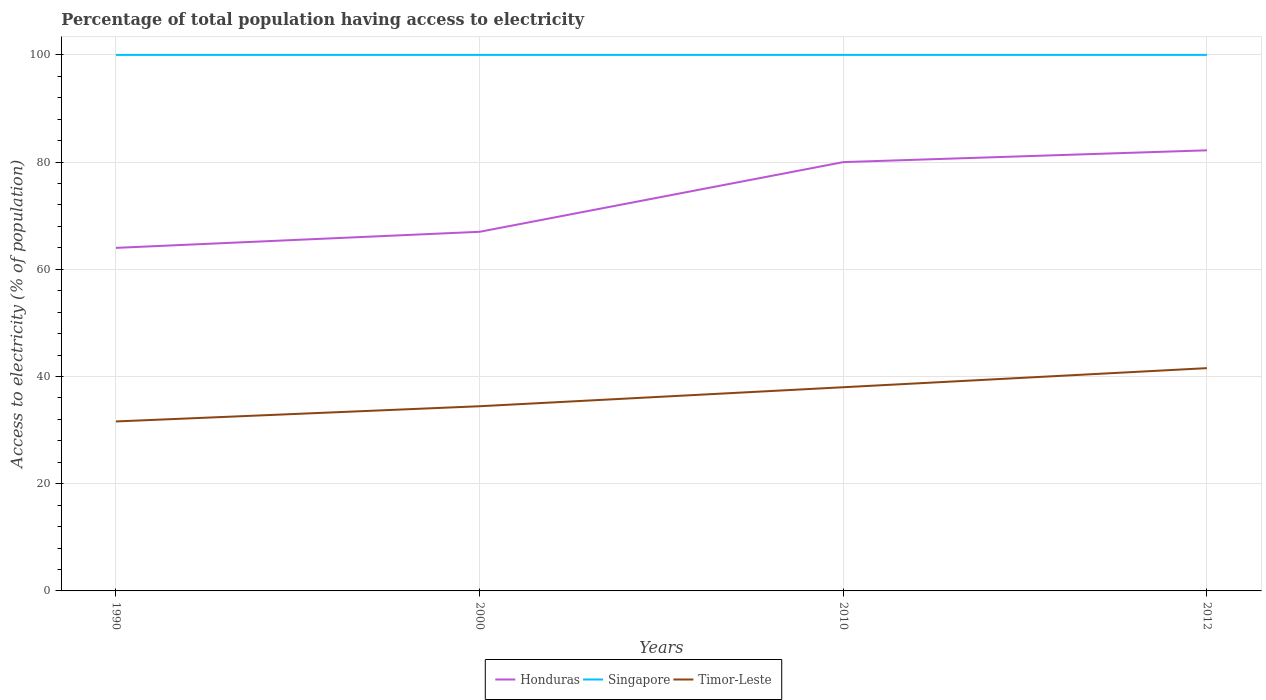How many different coloured lines are there?
Keep it short and to the point. 3. Does the line corresponding to Honduras intersect with the line corresponding to Singapore?
Your answer should be compact. No. Across all years, what is the maximum percentage of population that have access to electricity in Honduras?
Offer a terse response. 64. In which year was the percentage of population that have access to electricity in Singapore maximum?
Keep it short and to the point. 1990. What is the difference between the highest and the second highest percentage of population that have access to electricity in Honduras?
Keep it short and to the point. 18.2. What is the difference between the highest and the lowest percentage of population that have access to electricity in Timor-Leste?
Give a very brief answer. 2. Is the percentage of population that have access to electricity in Timor-Leste strictly greater than the percentage of population that have access to electricity in Honduras over the years?
Give a very brief answer. Yes. Does the graph contain grids?
Ensure brevity in your answer.  Yes. Where does the legend appear in the graph?
Make the answer very short. Bottom center. How many legend labels are there?
Provide a succinct answer. 3. How are the legend labels stacked?
Offer a terse response. Horizontal. What is the title of the graph?
Your answer should be very brief. Percentage of total population having access to electricity. What is the label or title of the Y-axis?
Provide a short and direct response. Access to electricity (% of population). What is the Access to electricity (% of population) in Honduras in 1990?
Offer a very short reply. 64. What is the Access to electricity (% of population) of Singapore in 1990?
Offer a very short reply. 100. What is the Access to electricity (% of population) in Timor-Leste in 1990?
Offer a terse response. 31.62. What is the Access to electricity (% of population) of Honduras in 2000?
Offer a very short reply. 67. What is the Access to electricity (% of population) in Timor-Leste in 2000?
Provide a short and direct response. 34.46. What is the Access to electricity (% of population) in Timor-Leste in 2010?
Your response must be concise. 38. What is the Access to electricity (% of population) of Honduras in 2012?
Keep it short and to the point. 82.2. What is the Access to electricity (% of population) of Timor-Leste in 2012?
Ensure brevity in your answer.  41.56. Across all years, what is the maximum Access to electricity (% of population) of Honduras?
Provide a short and direct response. 82.2. Across all years, what is the maximum Access to electricity (% of population) in Timor-Leste?
Ensure brevity in your answer.  41.56. Across all years, what is the minimum Access to electricity (% of population) of Timor-Leste?
Your answer should be very brief. 31.62. What is the total Access to electricity (% of population) of Honduras in the graph?
Make the answer very short. 293.2. What is the total Access to electricity (% of population) in Timor-Leste in the graph?
Offer a very short reply. 145.63. What is the difference between the Access to electricity (% of population) in Singapore in 1990 and that in 2000?
Make the answer very short. 0. What is the difference between the Access to electricity (% of population) in Timor-Leste in 1990 and that in 2000?
Your answer should be very brief. -2.84. What is the difference between the Access to electricity (% of population) of Honduras in 1990 and that in 2010?
Offer a very short reply. -16. What is the difference between the Access to electricity (% of population) of Timor-Leste in 1990 and that in 2010?
Provide a short and direct response. -6.38. What is the difference between the Access to electricity (% of population) of Honduras in 1990 and that in 2012?
Ensure brevity in your answer.  -18.2. What is the difference between the Access to electricity (% of population) of Singapore in 1990 and that in 2012?
Provide a succinct answer. 0. What is the difference between the Access to electricity (% of population) in Timor-Leste in 1990 and that in 2012?
Your answer should be very brief. -9.95. What is the difference between the Access to electricity (% of population) in Honduras in 2000 and that in 2010?
Your answer should be compact. -13. What is the difference between the Access to electricity (% of population) of Singapore in 2000 and that in 2010?
Offer a very short reply. 0. What is the difference between the Access to electricity (% of population) in Timor-Leste in 2000 and that in 2010?
Offer a terse response. -3.54. What is the difference between the Access to electricity (% of population) of Honduras in 2000 and that in 2012?
Give a very brief answer. -15.2. What is the difference between the Access to electricity (% of population) in Singapore in 2000 and that in 2012?
Give a very brief answer. 0. What is the difference between the Access to electricity (% of population) of Timor-Leste in 2000 and that in 2012?
Give a very brief answer. -7.11. What is the difference between the Access to electricity (% of population) in Honduras in 2010 and that in 2012?
Your response must be concise. -2.2. What is the difference between the Access to electricity (% of population) of Singapore in 2010 and that in 2012?
Provide a short and direct response. 0. What is the difference between the Access to electricity (% of population) of Timor-Leste in 2010 and that in 2012?
Provide a short and direct response. -3.56. What is the difference between the Access to electricity (% of population) of Honduras in 1990 and the Access to electricity (% of population) of Singapore in 2000?
Your response must be concise. -36. What is the difference between the Access to electricity (% of population) in Honduras in 1990 and the Access to electricity (% of population) in Timor-Leste in 2000?
Your response must be concise. 29.54. What is the difference between the Access to electricity (% of population) of Singapore in 1990 and the Access to electricity (% of population) of Timor-Leste in 2000?
Give a very brief answer. 65.54. What is the difference between the Access to electricity (% of population) in Honduras in 1990 and the Access to electricity (% of population) in Singapore in 2010?
Ensure brevity in your answer.  -36. What is the difference between the Access to electricity (% of population) of Singapore in 1990 and the Access to electricity (% of population) of Timor-Leste in 2010?
Provide a short and direct response. 62. What is the difference between the Access to electricity (% of population) of Honduras in 1990 and the Access to electricity (% of population) of Singapore in 2012?
Offer a very short reply. -36. What is the difference between the Access to electricity (% of population) of Honduras in 1990 and the Access to electricity (% of population) of Timor-Leste in 2012?
Ensure brevity in your answer.  22.44. What is the difference between the Access to electricity (% of population) of Singapore in 1990 and the Access to electricity (% of population) of Timor-Leste in 2012?
Make the answer very short. 58.44. What is the difference between the Access to electricity (% of population) of Honduras in 2000 and the Access to electricity (% of population) of Singapore in 2010?
Provide a succinct answer. -33. What is the difference between the Access to electricity (% of population) of Honduras in 2000 and the Access to electricity (% of population) of Singapore in 2012?
Your response must be concise. -33. What is the difference between the Access to electricity (% of population) of Honduras in 2000 and the Access to electricity (% of population) of Timor-Leste in 2012?
Offer a very short reply. 25.44. What is the difference between the Access to electricity (% of population) of Singapore in 2000 and the Access to electricity (% of population) of Timor-Leste in 2012?
Your answer should be very brief. 58.44. What is the difference between the Access to electricity (% of population) in Honduras in 2010 and the Access to electricity (% of population) in Timor-Leste in 2012?
Provide a short and direct response. 38.44. What is the difference between the Access to electricity (% of population) of Singapore in 2010 and the Access to electricity (% of population) of Timor-Leste in 2012?
Your answer should be compact. 58.44. What is the average Access to electricity (% of population) in Honduras per year?
Your answer should be compact. 73.3. What is the average Access to electricity (% of population) in Singapore per year?
Your response must be concise. 100. What is the average Access to electricity (% of population) in Timor-Leste per year?
Offer a terse response. 36.41. In the year 1990, what is the difference between the Access to electricity (% of population) in Honduras and Access to electricity (% of population) in Singapore?
Give a very brief answer. -36. In the year 1990, what is the difference between the Access to electricity (% of population) in Honduras and Access to electricity (% of population) in Timor-Leste?
Give a very brief answer. 32.38. In the year 1990, what is the difference between the Access to electricity (% of population) of Singapore and Access to electricity (% of population) of Timor-Leste?
Provide a short and direct response. 68.38. In the year 2000, what is the difference between the Access to electricity (% of population) of Honduras and Access to electricity (% of population) of Singapore?
Your response must be concise. -33. In the year 2000, what is the difference between the Access to electricity (% of population) of Honduras and Access to electricity (% of population) of Timor-Leste?
Your answer should be very brief. 32.54. In the year 2000, what is the difference between the Access to electricity (% of population) of Singapore and Access to electricity (% of population) of Timor-Leste?
Ensure brevity in your answer.  65.54. In the year 2010, what is the difference between the Access to electricity (% of population) of Singapore and Access to electricity (% of population) of Timor-Leste?
Your response must be concise. 62. In the year 2012, what is the difference between the Access to electricity (% of population) of Honduras and Access to electricity (% of population) of Singapore?
Give a very brief answer. -17.8. In the year 2012, what is the difference between the Access to electricity (% of population) in Honduras and Access to electricity (% of population) in Timor-Leste?
Offer a terse response. 40.64. In the year 2012, what is the difference between the Access to electricity (% of population) in Singapore and Access to electricity (% of population) in Timor-Leste?
Ensure brevity in your answer.  58.44. What is the ratio of the Access to electricity (% of population) in Honduras in 1990 to that in 2000?
Your answer should be compact. 0.96. What is the ratio of the Access to electricity (% of population) in Timor-Leste in 1990 to that in 2000?
Ensure brevity in your answer.  0.92. What is the ratio of the Access to electricity (% of population) of Timor-Leste in 1990 to that in 2010?
Offer a terse response. 0.83. What is the ratio of the Access to electricity (% of population) of Honduras in 1990 to that in 2012?
Ensure brevity in your answer.  0.78. What is the ratio of the Access to electricity (% of population) of Singapore in 1990 to that in 2012?
Your answer should be compact. 1. What is the ratio of the Access to electricity (% of population) of Timor-Leste in 1990 to that in 2012?
Your response must be concise. 0.76. What is the ratio of the Access to electricity (% of population) in Honduras in 2000 to that in 2010?
Provide a succinct answer. 0.84. What is the ratio of the Access to electricity (% of population) of Singapore in 2000 to that in 2010?
Make the answer very short. 1. What is the ratio of the Access to electricity (% of population) of Timor-Leste in 2000 to that in 2010?
Your response must be concise. 0.91. What is the ratio of the Access to electricity (% of population) of Honduras in 2000 to that in 2012?
Give a very brief answer. 0.82. What is the ratio of the Access to electricity (% of population) in Singapore in 2000 to that in 2012?
Give a very brief answer. 1. What is the ratio of the Access to electricity (% of population) of Timor-Leste in 2000 to that in 2012?
Give a very brief answer. 0.83. What is the ratio of the Access to electricity (% of population) of Honduras in 2010 to that in 2012?
Ensure brevity in your answer.  0.97. What is the ratio of the Access to electricity (% of population) in Timor-Leste in 2010 to that in 2012?
Offer a very short reply. 0.91. What is the difference between the highest and the second highest Access to electricity (% of population) in Honduras?
Give a very brief answer. 2.2. What is the difference between the highest and the second highest Access to electricity (% of population) in Singapore?
Provide a short and direct response. 0. What is the difference between the highest and the second highest Access to electricity (% of population) of Timor-Leste?
Make the answer very short. 3.56. What is the difference between the highest and the lowest Access to electricity (% of population) of Singapore?
Your answer should be very brief. 0. What is the difference between the highest and the lowest Access to electricity (% of population) in Timor-Leste?
Ensure brevity in your answer.  9.95. 